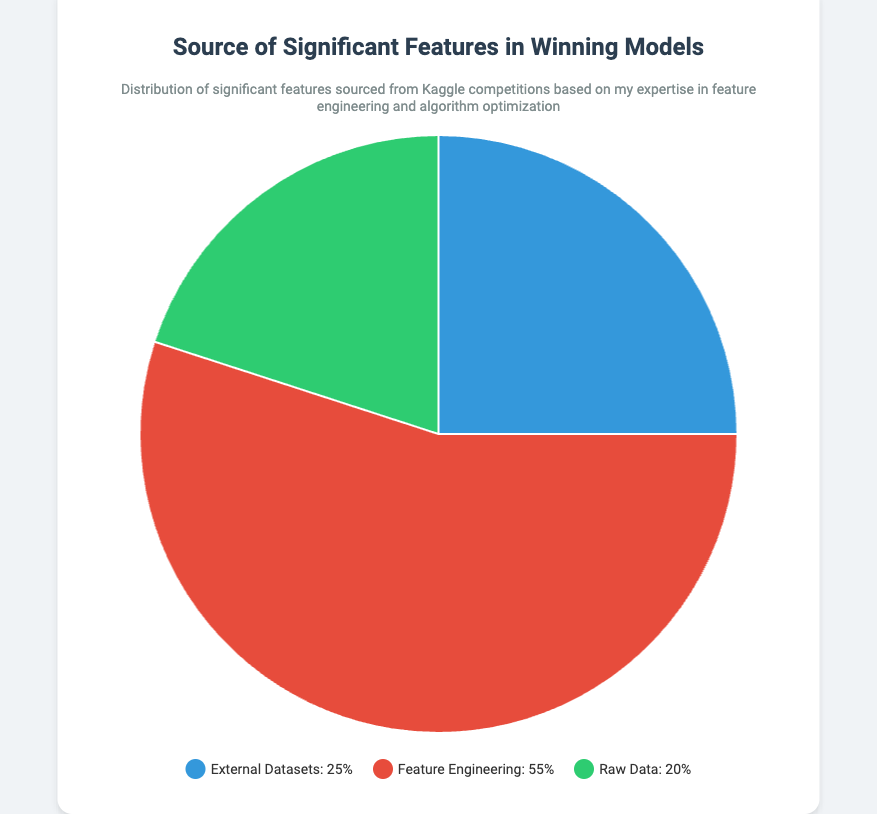What percentage of significant features come from External Datasets? The figure shows a pie chart with the data points labeled. The External Datasets segment is listed with a percentage value of 25%.
Answer: 25% Which source contributes the most to winning models? The figure illustrates three sources with their percentages. Feature Engineering has the highest percentage at 55%, compared to External Datasets (25%) and Raw Data (20%).
Answer: Feature Engineering How much more significant are features from Feature Engineering compared to Raw Data? The percentage for Feature Engineering is 55% and for Raw Data is 20%. Subtract 20% from 55% to find the difference. 55% - 20% = 35%
Answer: 35% Which color represents the Raw Data source in the pie chart? In the pie chart, Raw Data is represented by the green segment.
Answer: Green What is the combined percentage of significant features sourced from External Datasets and Raw Data? The External Datasets contributions are 25% and Raw Data contributions are 20%. Adding these gives 25% + 20% = 45%.
Answer: 45% Is the contribution from Raw Data greater or less than that from External Datasets? The percentage for Raw Data is 20%, which is less than the 25% for External Datasets.
Answer: Less What fraction of the significant features are derived from sources other than Feature Engineering? Feature Engineering contributes 55%. The rest is from External Datasets (25%) and Raw Data (20%). Adding these gives 25% + 20% = 45%.
Answer: 45% By what percentage does the largest source exceed the smallest source? The largest source (Feature Engineering) is 55% and the smallest source (Raw Data) is 20%. The difference is 55% - 20% = 35%.
Answer: 35% What is the median percentage value of the sources? For the three percentages (25%, 55%, 20%), arrange them in ascending order: 20%, 25%, 55%. The median is the middle value, which is 25%.
Answer: 25% If transformed into a bar graph, which bar would be the tallest? Feature Engineering has the highest contribution at 55%, indicating it would have the tallest bar.
Answer: Feature Engineering 